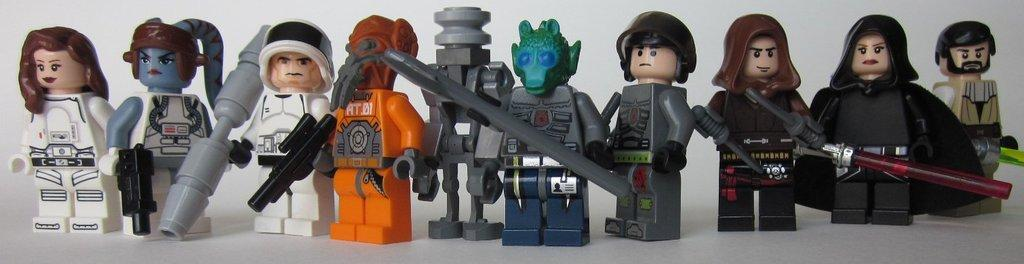What type of objects are present in the image? There are many toys in the image. Can you describe the main toy in the image? There is a robot toy in the center of the image. Which toy has a red color? There is a red-colored toy in the image. What is the theme of one of the toys in the image? There is an astronaut toy in the image. How does the cloth interact with the toys in the image? There is no cloth present in the image; it only features toys. What type of love is expressed by the toys in the image? Toys do not express love; they are inanimate objects. 